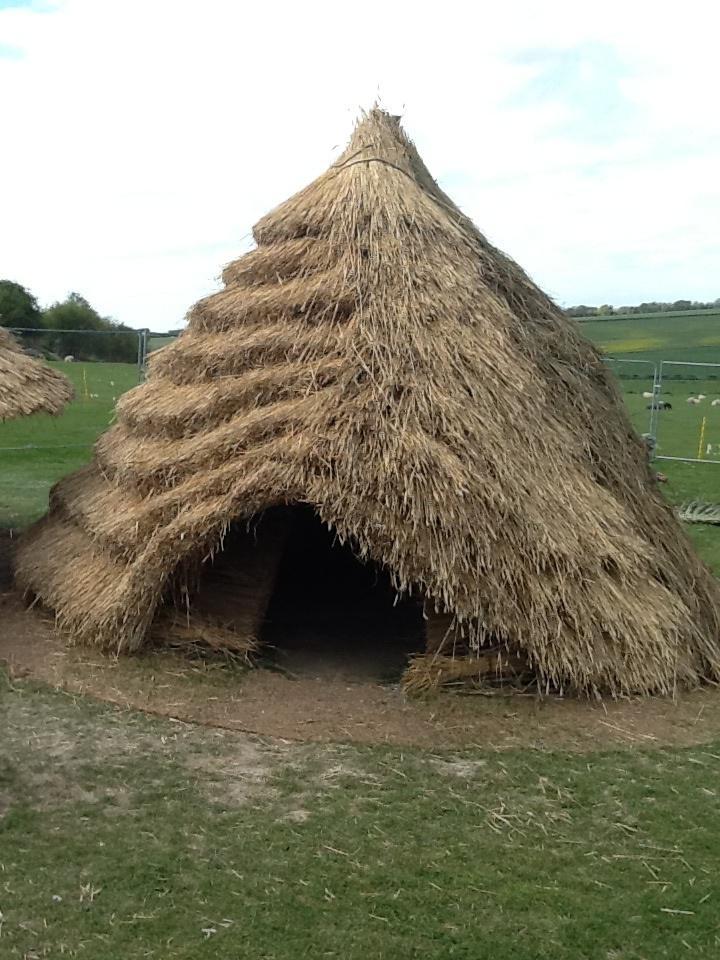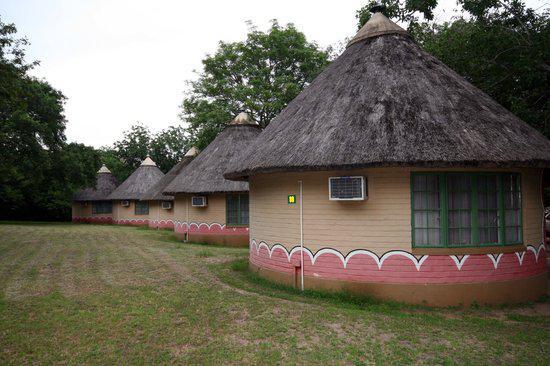The first image is the image on the left, the second image is the image on the right. For the images shown, is this caption "The right image shows several low round buildings with cone-shaped roofs in an area with brown dirt instead of grass." true? Answer yes or no. No. The first image is the image on the left, the second image is the image on the right. For the images shown, is this caption "A person is standing outside near a building in one of the images." true? Answer yes or no. No. 